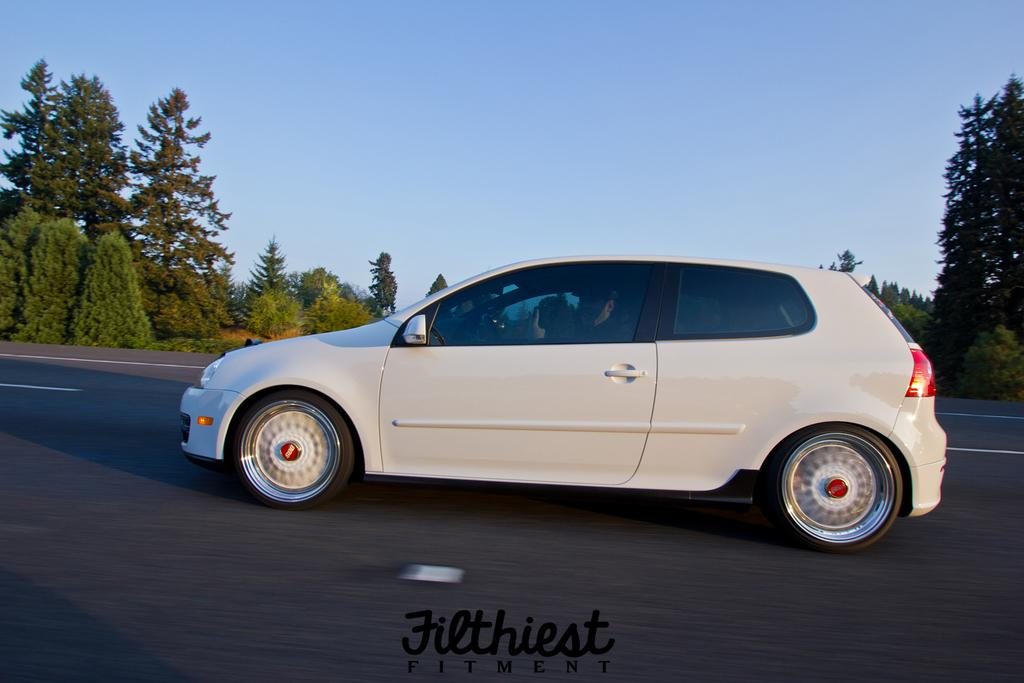What color is the sky in the image? The sky is blue in the image. What can be seen on the road in the image? There is a vehicle on the road in the image. What type of natural elements are visible in the background of the image? Trees and plants are present in the background of the image. Can you describe any additional features of the image? There is a watermark at the bottom of the image. What type of watch is the driver wearing in the image? There is no driver or watch visible in the image; it only shows a vehicle on the road and a blue sky. 